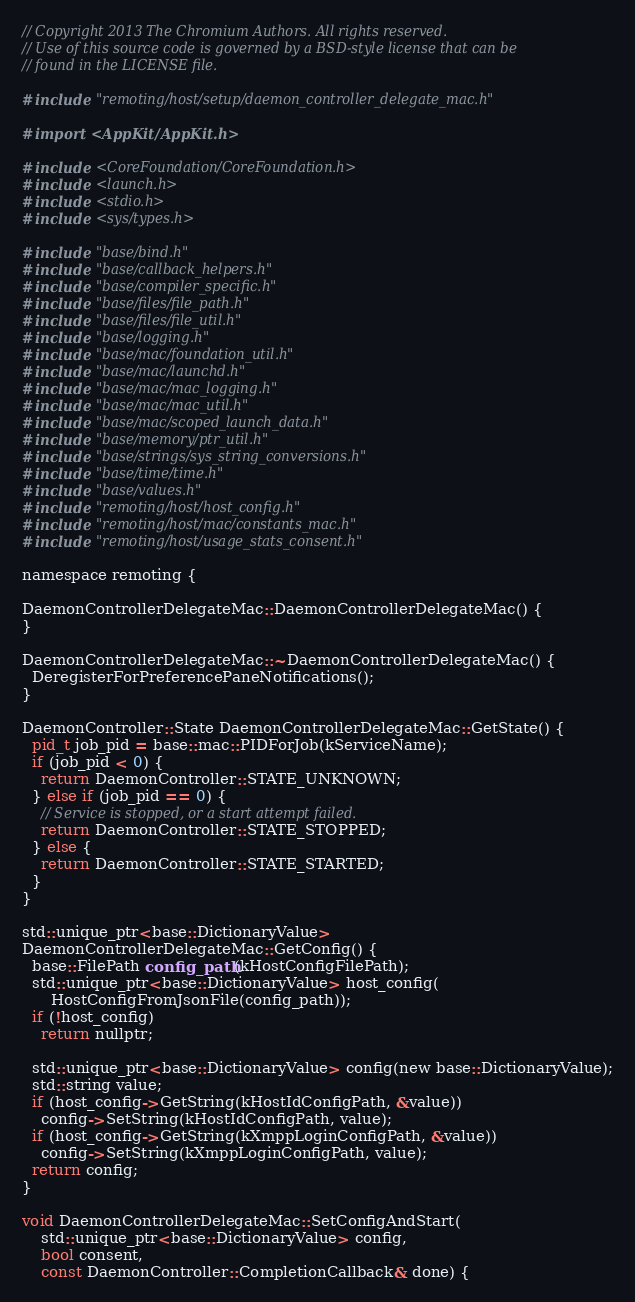Convert code to text. <code><loc_0><loc_0><loc_500><loc_500><_ObjectiveC_>// Copyright 2013 The Chromium Authors. All rights reserved.
// Use of this source code is governed by a BSD-style license that can be
// found in the LICENSE file.

#include "remoting/host/setup/daemon_controller_delegate_mac.h"

#import <AppKit/AppKit.h>

#include <CoreFoundation/CoreFoundation.h>
#include <launch.h>
#include <stdio.h>
#include <sys/types.h>

#include "base/bind.h"
#include "base/callback_helpers.h"
#include "base/compiler_specific.h"
#include "base/files/file_path.h"
#include "base/files/file_util.h"
#include "base/logging.h"
#include "base/mac/foundation_util.h"
#include "base/mac/launchd.h"
#include "base/mac/mac_logging.h"
#include "base/mac/mac_util.h"
#include "base/mac/scoped_launch_data.h"
#include "base/memory/ptr_util.h"
#include "base/strings/sys_string_conversions.h"
#include "base/time/time.h"
#include "base/values.h"
#include "remoting/host/host_config.h"
#include "remoting/host/mac/constants_mac.h"
#include "remoting/host/usage_stats_consent.h"

namespace remoting {

DaemonControllerDelegateMac::DaemonControllerDelegateMac() {
}

DaemonControllerDelegateMac::~DaemonControllerDelegateMac() {
  DeregisterForPreferencePaneNotifications();
}

DaemonController::State DaemonControllerDelegateMac::GetState() {
  pid_t job_pid = base::mac::PIDForJob(kServiceName);
  if (job_pid < 0) {
    return DaemonController::STATE_UNKNOWN;
  } else if (job_pid == 0) {
    // Service is stopped, or a start attempt failed.
    return DaemonController::STATE_STOPPED;
  } else {
    return DaemonController::STATE_STARTED;
  }
}

std::unique_ptr<base::DictionaryValue>
DaemonControllerDelegateMac::GetConfig() {
  base::FilePath config_path(kHostConfigFilePath);
  std::unique_ptr<base::DictionaryValue> host_config(
      HostConfigFromJsonFile(config_path));
  if (!host_config)
    return nullptr;

  std::unique_ptr<base::DictionaryValue> config(new base::DictionaryValue);
  std::string value;
  if (host_config->GetString(kHostIdConfigPath, &value))
    config->SetString(kHostIdConfigPath, value);
  if (host_config->GetString(kXmppLoginConfigPath, &value))
    config->SetString(kXmppLoginConfigPath, value);
  return config;
}

void DaemonControllerDelegateMac::SetConfigAndStart(
    std::unique_ptr<base::DictionaryValue> config,
    bool consent,
    const DaemonController::CompletionCallback& done) {</code> 